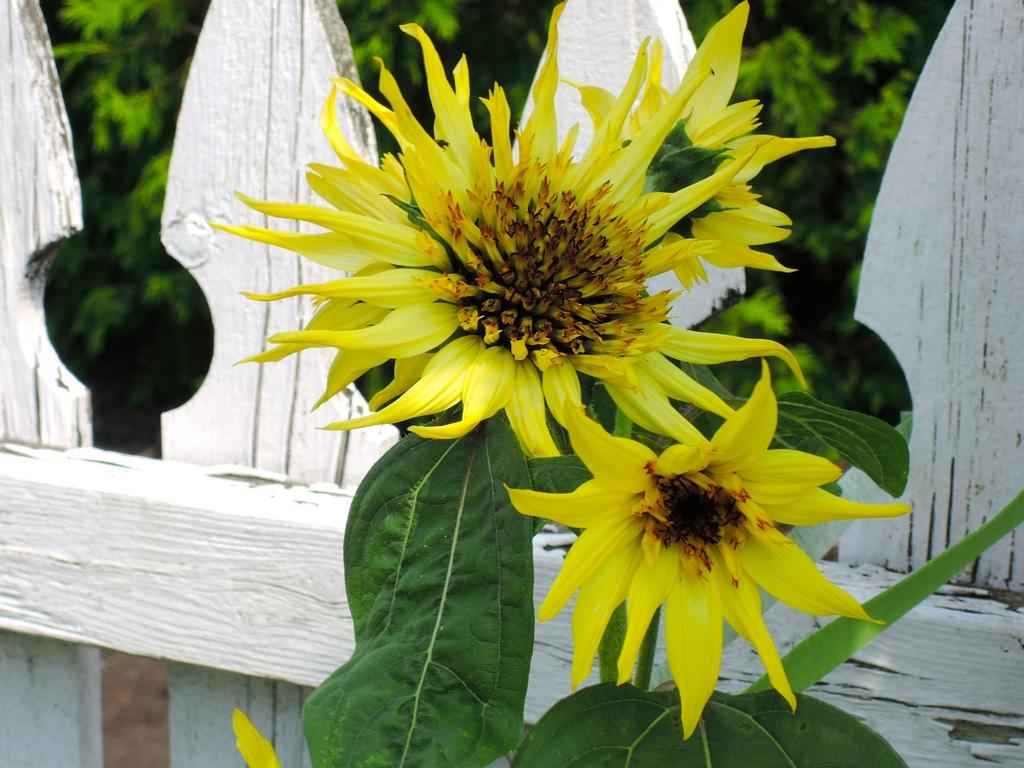What is located in the center of the image? There are flowers and leaves in the center of the image. What can be seen in the background of the image? There is fencing and trees visible in the background of the image. Where is the ground visible in the image? The ground is visible in the bottom left corner of the image. What type of trouble can be seen in the image? There is no trouble present in the image; it features flowers, leaves, fencing, trees, and the ground. What kind of structure is depicted in the image? There is no specific structure depicted in the image; it primarily shows natural elements like flowers, leaves, and trees. 